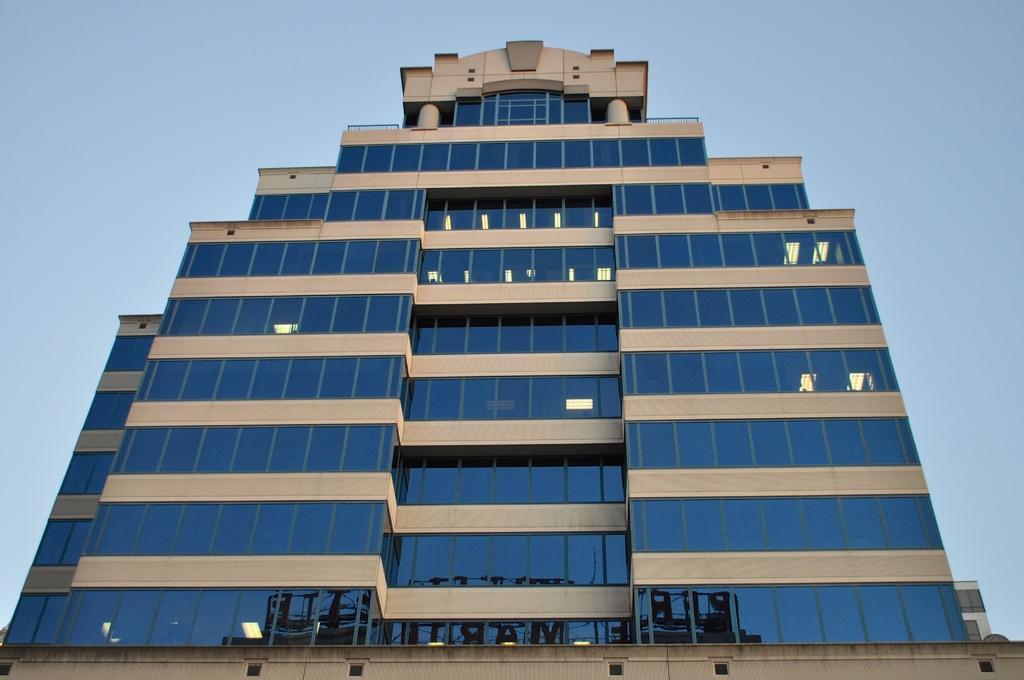Please provide a concise description of this image. In the foreground of the picture there is a building. Sky is clear. 